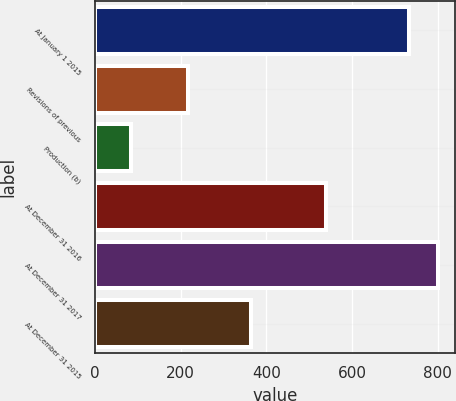<chart> <loc_0><loc_0><loc_500><loc_500><bar_chart><fcel>At January 1 2015<fcel>Revisions of previous<fcel>Production (b)<fcel>At December 31 2016<fcel>At December 31 2017<fcel>At December 31 2015<nl><fcel>734<fcel>218<fcel>85<fcel>539<fcel>800.6<fcel>365<nl></chart> 